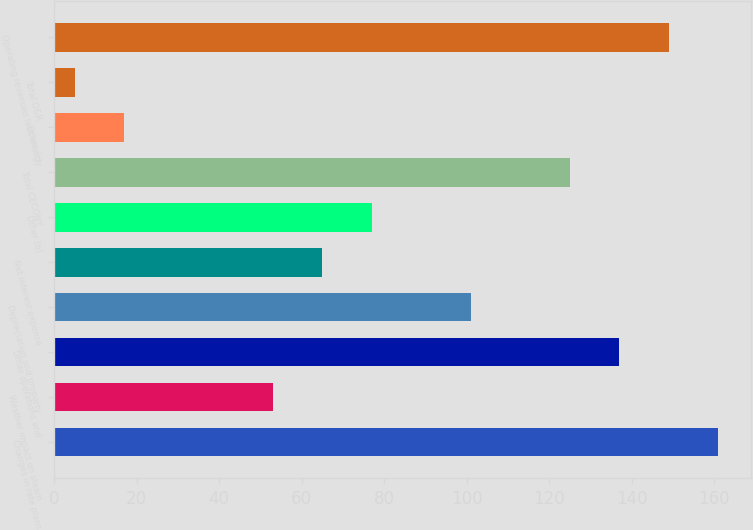<chart> <loc_0><loc_0><loc_500><loc_500><bar_chart><fcel>Changes in rate plans<fcel>Weather impact on steam<fcel>Other operations and<fcel>Depreciation and property<fcel>Net interest expense<fcel>Other (b)<fcel>Total CECONY<fcel>Other (c)<fcel>Total O&R<fcel>Operating revenues less energy<nl><fcel>161<fcel>53<fcel>137<fcel>101<fcel>65<fcel>77<fcel>125<fcel>17<fcel>5<fcel>149<nl></chart> 